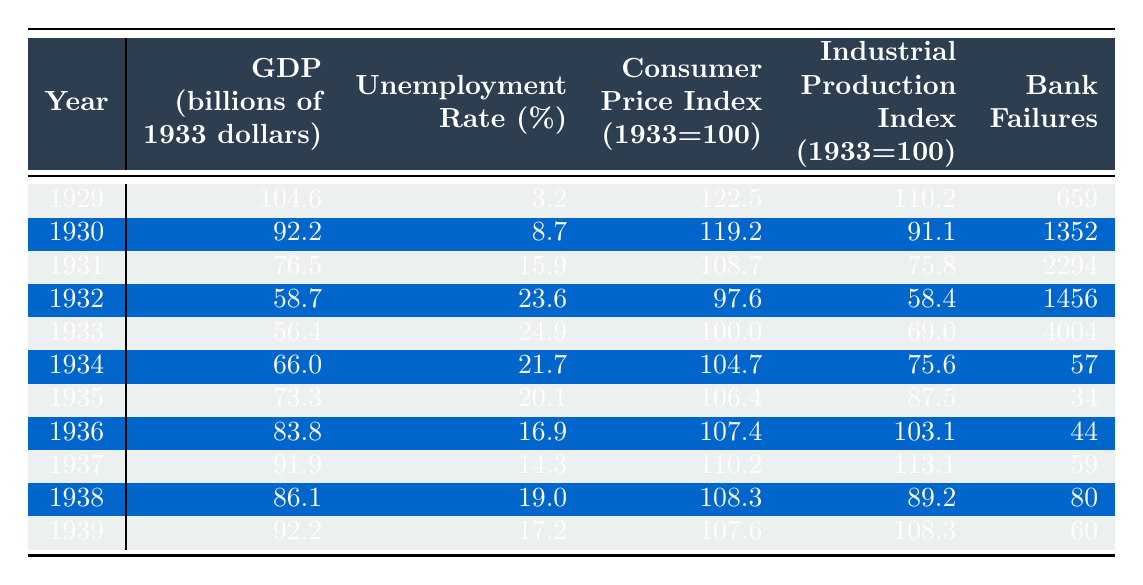What was the GDP in 1932? The table indicates that the GDP for the year 1932 was 58.7 billion dollars (in 1933 dollars).
Answer: 58.7 billion dollars Which year had the highest unemployment rate? By examining the unemployment rates listed in the table, 1933 showed the highest rate at 24.9%.
Answer: 1933 How much did the unemployment rate decrease from 1932 to 1936? The unemployment rate in 1932 was 23.6%, and in 1936 it dropped to 16.9%. The difference is 23.6% - 16.9% = 6.7%.
Answer: 6.7% What is the average GDP from 1930 to 1939? The GDP values from 1930 to 1939 are: 92.2, 76.5, 58.7, 56.4, 66.0, 73.3, 83.8, 91.9, 86.1, 92.2. The sum is 92.2 + 76.5 + 58.7 + 56.4 + 66.0 + 73.3 + 83.8 + 91.9 + 86.1 + 92.2 = 792.1, and there are 10 years, so the average is 792.1 / 10 = 79.21 billion dollars.
Answer: 79.21 billion dollars Did the number of bank failures increase every year from 1929 to 1933? The number of bank failures increased from 659 in 1929 to 4004 in 1933 as shown in the table, indicating a consistent increase over those years.
Answer: Yes What was the trend of the Industrial Production Index from 1931 to 1939? Looking at the values in the table for 1931 (75.8), 1932 (58.4), 1933 (69.0), 1934 (75.6), 1935 (87.5), 1936 (103.1), 1937 (113.1), 1938 (89.2), and 1939 (108.3), the trend went down in 1932, then up from 1933 to 1937, down in 1938, and finally up again in 1939, showing fluctuations rather than a consistent trend.
Answer: Fluctuations What is the difference in the Consumer Price Index between 1929 and 1939? The Consumer Price Index in 1929 is 122.5, and in 1939 it is 107.6, so the difference is 122.5 - 107.6 = 14.9.
Answer: 14.9 In which year was the GDP the lowest, and what was its value? The table shows that the GDP was lowest in 1933 at 56.4 billion dollars.
Answer: 1933, 56.4 billion dollars What was the average unemployment rate from 1932 to 1938? The unemployment rates for the years are: 23.6 (1932), 24.9 (1933), 21.7 (1934), 20.1 (1935), 16.9 (1936), 14.3 (1937), and 19.0 (1938). The sum is 23.6 + 24.9 + 21.7 + 20.1 + 16.9 + 14.3 + 19.0 = 140.5, divided by 7 years gives an average of approximately 20.07%.
Answer: 20.07% 